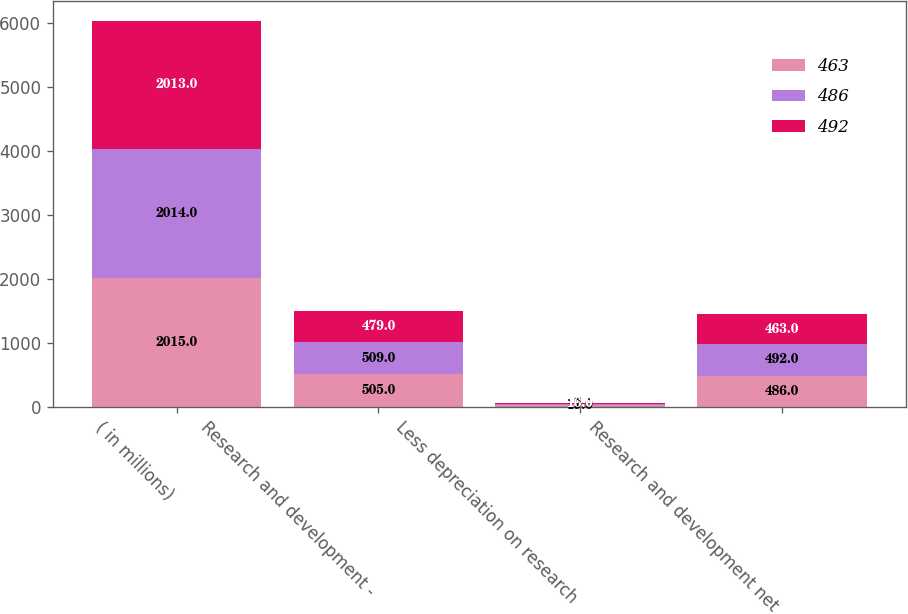Convert chart to OTSL. <chart><loc_0><loc_0><loc_500><loc_500><stacked_bar_chart><ecel><fcel>( in millions)<fcel>Research and development -<fcel>Less depreciation on research<fcel>Research and development net<nl><fcel>463<fcel>2015<fcel>505<fcel>19<fcel>486<nl><fcel>486<fcel>2014<fcel>509<fcel>17<fcel>492<nl><fcel>492<fcel>2013<fcel>479<fcel>16<fcel>463<nl></chart> 